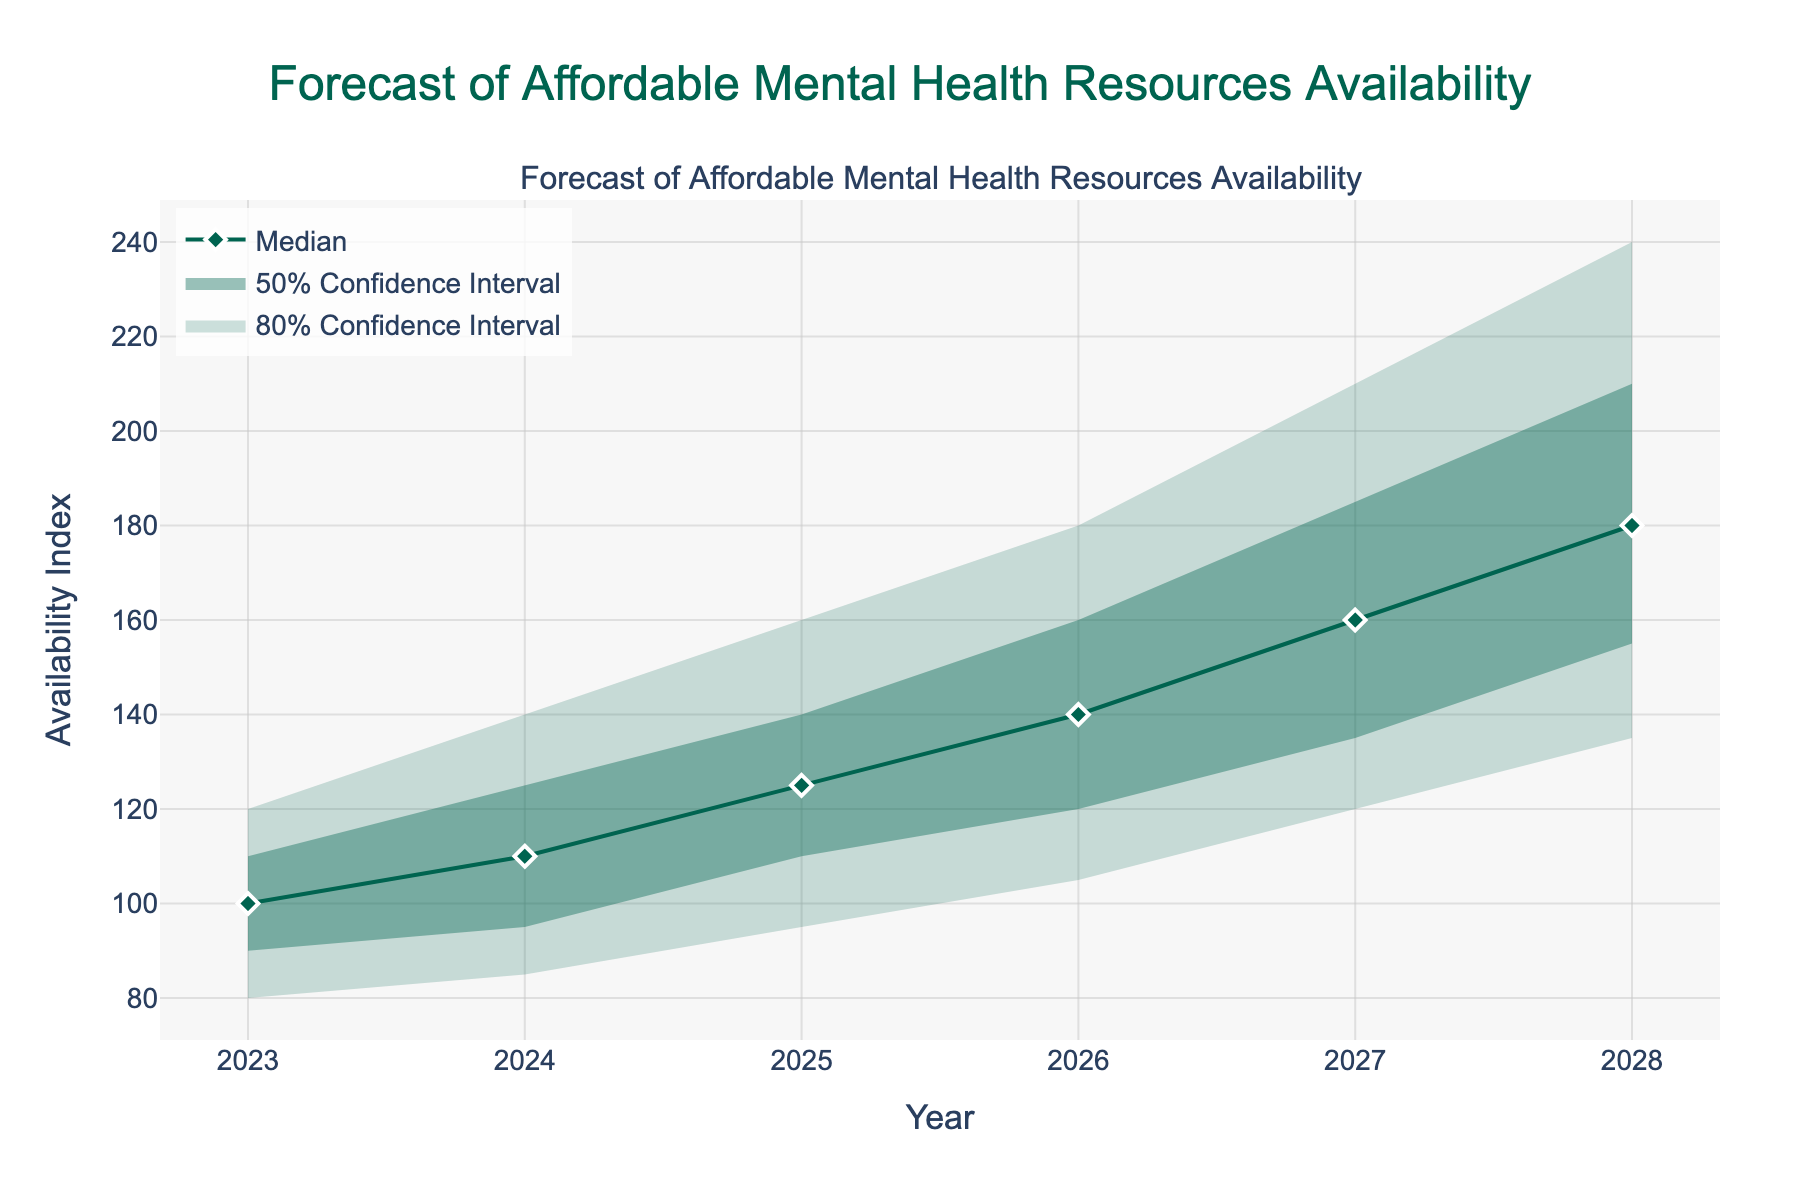What is the title of the figure? The title of the figure is presented at the top, in the center, usually in a larger font size and sometimes in bold to grab attention. This particular title states, "Forecast of Affordable Mental Health Resources Availability".
Answer: Forecast of Affordable Mental Health Resources Availability What is the median value for the year 2026? To find the median value for the year 2026, look at the line labeled 'Median' and locate its value for 2026, which is directly shown on the y-axis of the graph.
Answer: 140 What is the range of the availability index for the year 2028 within the 80% confidence interval? The 80% confidence interval is represented by the space between the lower 10% line and the upper 90% line for the year 2028. This range can be determined by subtracting the lower value from the upper value. For 2028, the upper value is 240, and the lower value is 135. Therefore, the range is: 240 - 135 = 105.
Answer: 105 How does the median availability index change from 2024 to 2025? To determine the change in the median availability index from 2024 to 2025, subtract the median value for 2024 from the median value for 2025. For 2024, the median is 110, and for 2025, the median is 125. Therefore, the change is: 125 - 110 = 15.
Answer: 15 Which year has the highest upper bound within the 50% confidence interval? The 50% confidence interval is between the upper 75% and lower 25% lines. To find the year with the highest upper bound value of the 50% confidence interval, look for the peak value on the upper 75% line. The highest value on the upper 75% line is 210, which is in the year 2028.
Answer: 2028 Does any year have a median availability index equal to the upper 75% availability index for the previous year? To answer this, compare median values with the upper 75% values from the preceding year. For example, in 2024, the median is 110, and in 2023, the upper 75% is also 110. This match confirms that the median availability index in 2024 equals the upper 75% availability index for the previous year (2023).
Answer: Yes, 2024 What is the prediction trend for the availability of affordable mental health resources over time based on the median line? The prediction trend over the years from 2023 to 2028 based on the median line can be evaluated by observing the general direction the median line takes. Noticing that the median values are increasing yearly suggests that the availability of affordable mental health resources is expected to increase over time.
Answer: Increasing What year is forecasted to have the narrowest 50% confidence interval for availability? To determine the narrowest 50% confidence interval, calculate the difference between the upper 75% and lower 25% values for each year and then compare them. The year with the smallest difference has the narrowest interval. 2023: 110-90=20, 2024: 125-95=30, 2025: 140-110=30, 2026: 160-120=40, 2027: 185-135=50, 2028: 210-155=55. So, 2023 has the narrowest 50% confidence interval.
Answer: 2023 